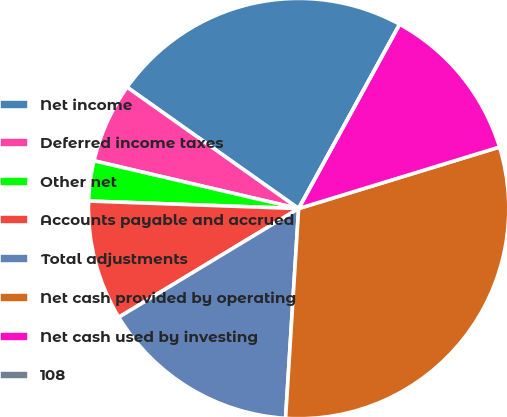Convert chart. <chart><loc_0><loc_0><loc_500><loc_500><pie_chart><fcel>Net income<fcel>Deferred income taxes<fcel>Other net<fcel>Accounts payable and accrued<fcel>Total adjustments<fcel>Net cash provided by operating<fcel>Net cash used by investing<fcel>108<nl><fcel>23.18%<fcel>6.15%<fcel>3.08%<fcel>9.22%<fcel>15.36%<fcel>30.72%<fcel>12.29%<fcel>0.0%<nl></chart> 